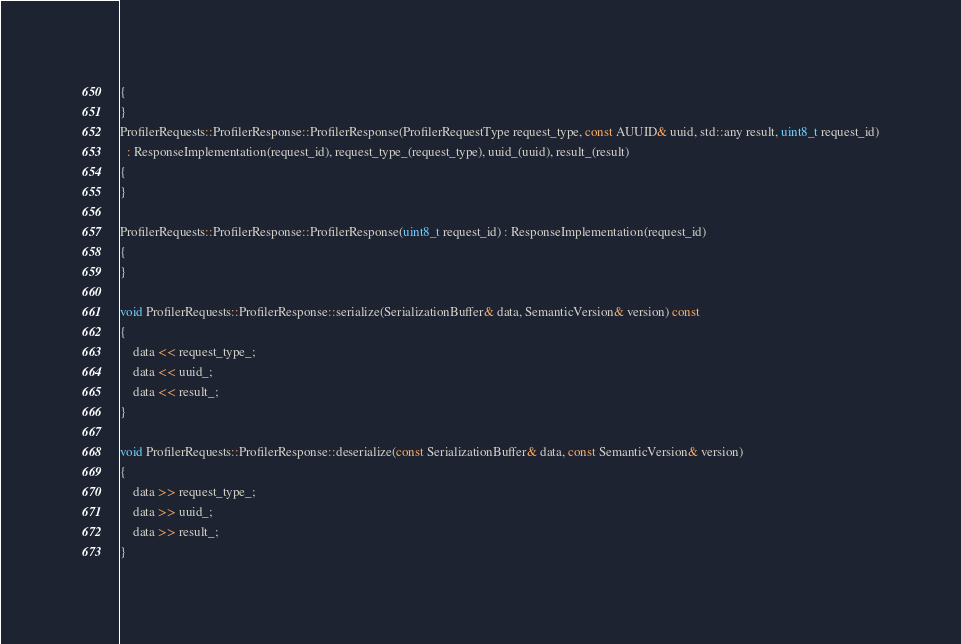Convert code to text. <code><loc_0><loc_0><loc_500><loc_500><_C++_>{
}
ProfilerRequests::ProfilerResponse::ProfilerResponse(ProfilerRequestType request_type, const AUUID& uuid, std::any result, uint8_t request_id)
  : ResponseImplementation(request_id), request_type_(request_type), uuid_(uuid), result_(result)
{
}

ProfilerRequests::ProfilerResponse::ProfilerResponse(uint8_t request_id) : ResponseImplementation(request_id)
{
}

void ProfilerRequests::ProfilerResponse::serialize(SerializationBuffer& data, SemanticVersion& version) const
{
    data << request_type_;
    data << uuid_;
    data << result_;
}

void ProfilerRequests::ProfilerResponse::deserialize(const SerializationBuffer& data, const SemanticVersion& version)
{
    data >> request_type_;
    data >> uuid_;
    data >> result_;
}
</code> 